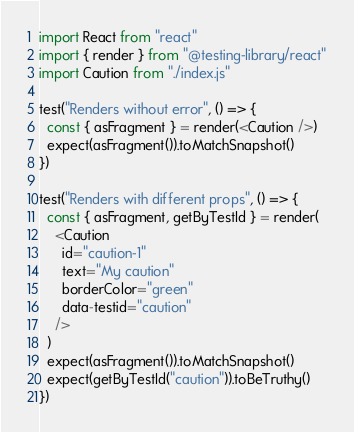<code> <loc_0><loc_0><loc_500><loc_500><_JavaScript_>import React from "react"
import { render } from "@testing-library/react"
import Caution from "./index.js"

test("Renders without error", () => {
  const { asFragment } = render(<Caution />)
  expect(asFragment()).toMatchSnapshot()
})

test("Renders with different props", () => {
  const { asFragment, getByTestId } = render(
    <Caution
      id="caution-1"
      text="My caution"
      borderColor="green"
      data-testid="caution"
    />
  )
  expect(asFragment()).toMatchSnapshot()
  expect(getByTestId("caution")).toBeTruthy()
})
</code> 